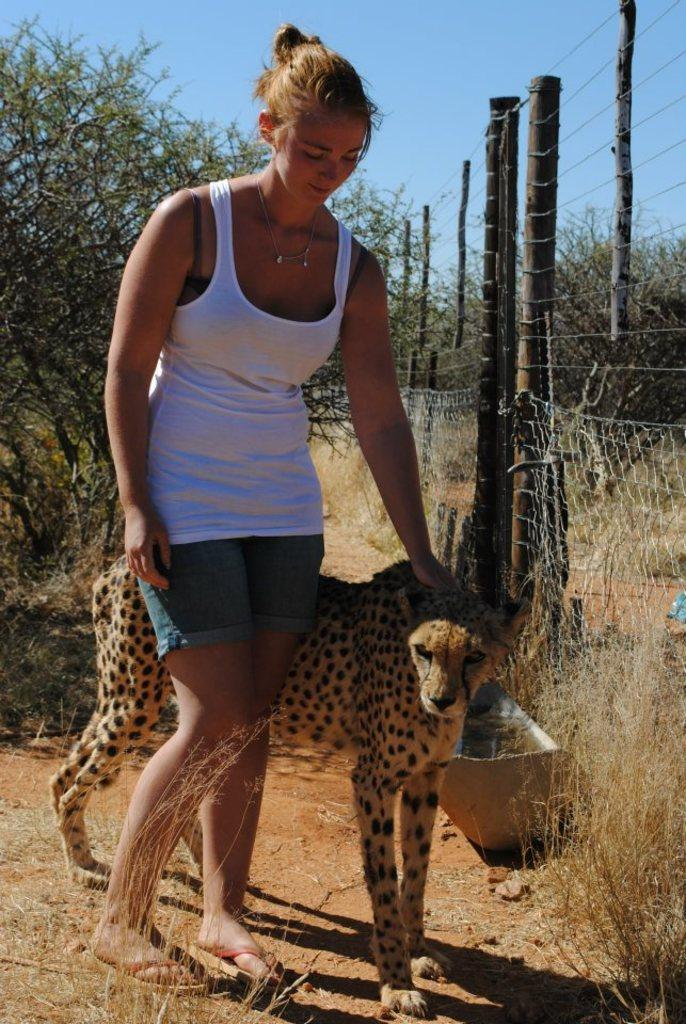Who is present in the image? There is a woman in the image. What is the woman doing in the image? The woman is standing in the image. What animal is present in the image? There is a cheetah in the image. How is the cheetah positioned in the image? The cheetah is standing on the ground in the image. What can be seen in the background of the image? There is a fence, plants, grass, and the sky visible in the background of the image. What type of screw can be seen holding the celery in the image? There is no screw or celery present in the image. How does the woman pull the cheetah in the image? The woman is not pulling the cheetah in the image; they are both standing independently. 